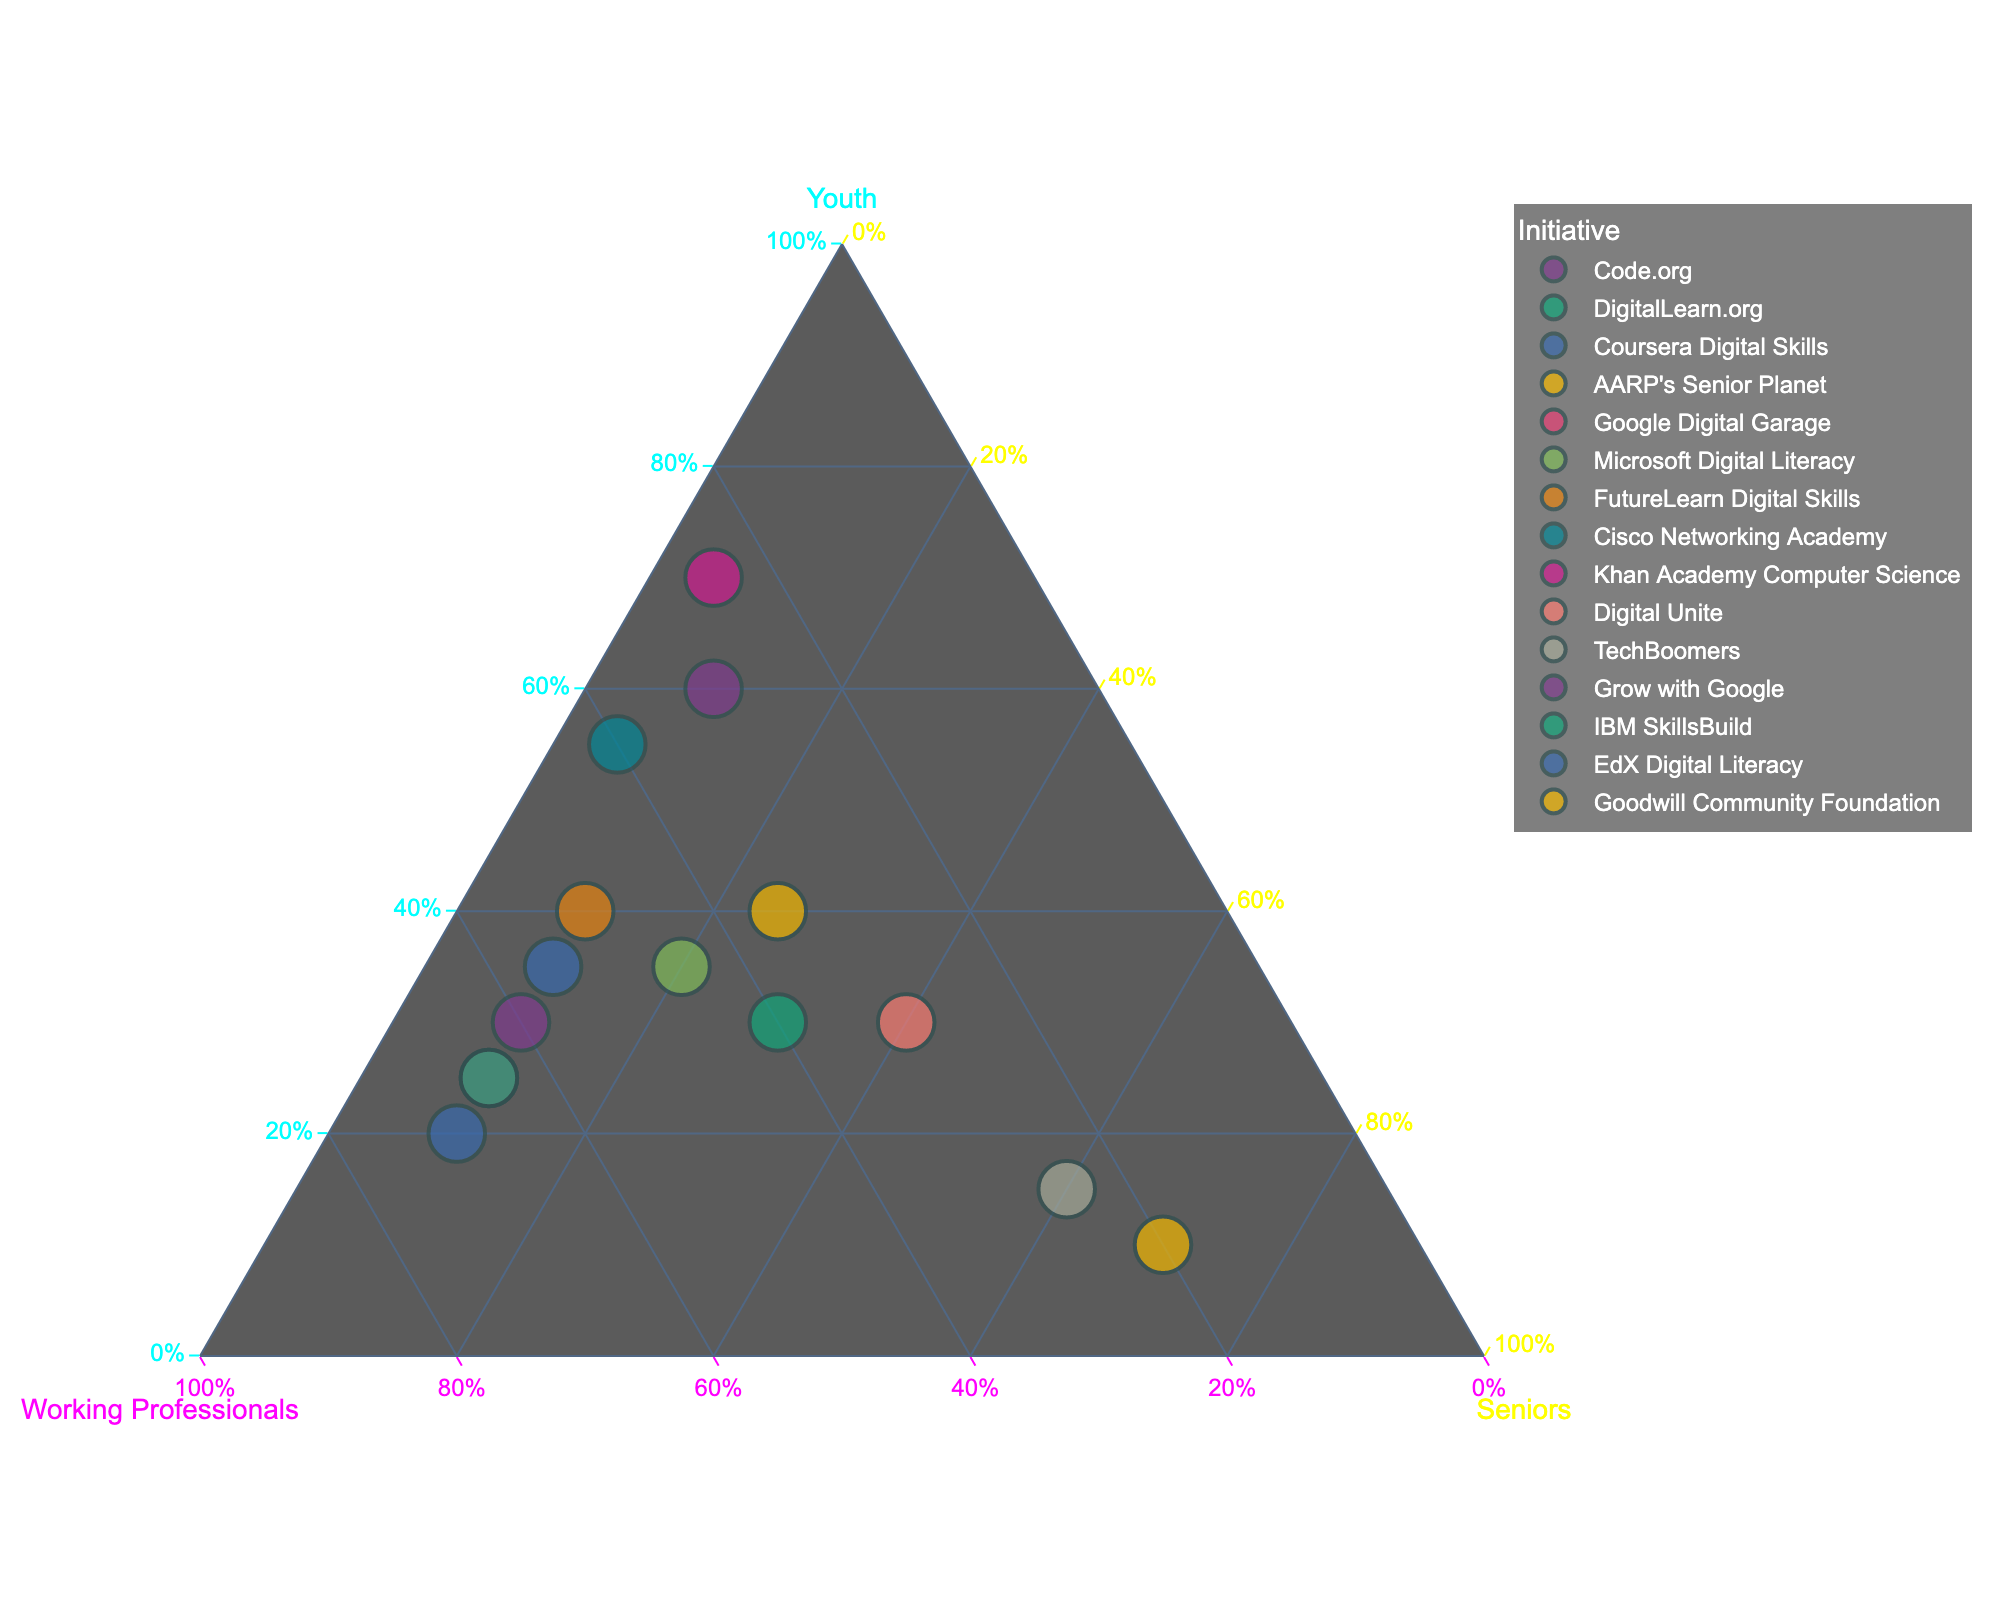Which initiative focuses the most on youth? Look for the point that is closest to the ‘Youth’ corner of the ternary plot.
Answer: Khan Academy Computer Science Which initiative targets seniors the most? Identify the data point closest to the ‘Seniors’ corner of the ternary plot.
Answer: AARP's Senior Planet Which initiatives have an equal distribution among all three demographics? Look for points that are located near the center of the ternary plot, indicating a balanced distribution.
Answer: DigitalLearn.org How many initiatives focus primarily on working professionals? Identify the points closest to the ‘Working Professionals’ corner. Count these points.
Answer: Four (Coursera Digital Skills, Google Digital Garage, IBM SkillsBuild, Grow with Google) Which initiative has the smallest percentage allocated to youth? Look for the point that is farthest from the ‘Youth’ corner.
Answer: AARP's Senior Planet Compare the initiatives Khan Academy Computer Science and Digital Unite in terms of their focus on seniors. Look at the data points and compare their positions in relation to the ‘Seniors’ corner.
Answer: Khan Academy Computer Science focuses less on seniors compared to Digital Unite Is there an initiative that has a similar distribution to Microsoft Digital Literacy? Look for another data point that is close in comparison to Microsoft Digital Literacy.
Answer: Goodwill Community Foundation What is the combined percentage focus on youth by Code.org and Cisco Networking Academy? Sum the percentages for youth focus for both initiatives: 60% (Code.org) + 55% (Cisco Networking Academy).
Answer: 115% Which initiative allocates approximately one-third of its resources to each demographic? Identify the point near the center of the plot where each demographic is equally represented.
Answer: DigitalLearn.org Which initiative serves the lowest percentage of working professionals? Look for the data point that is farthest from the ‘Working Professionals’ corner.
Answer: TechBoomers 